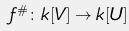<formula> <loc_0><loc_0><loc_500><loc_500>f ^ { \# } \colon k [ V ] \rightarrow k [ U ]</formula> 